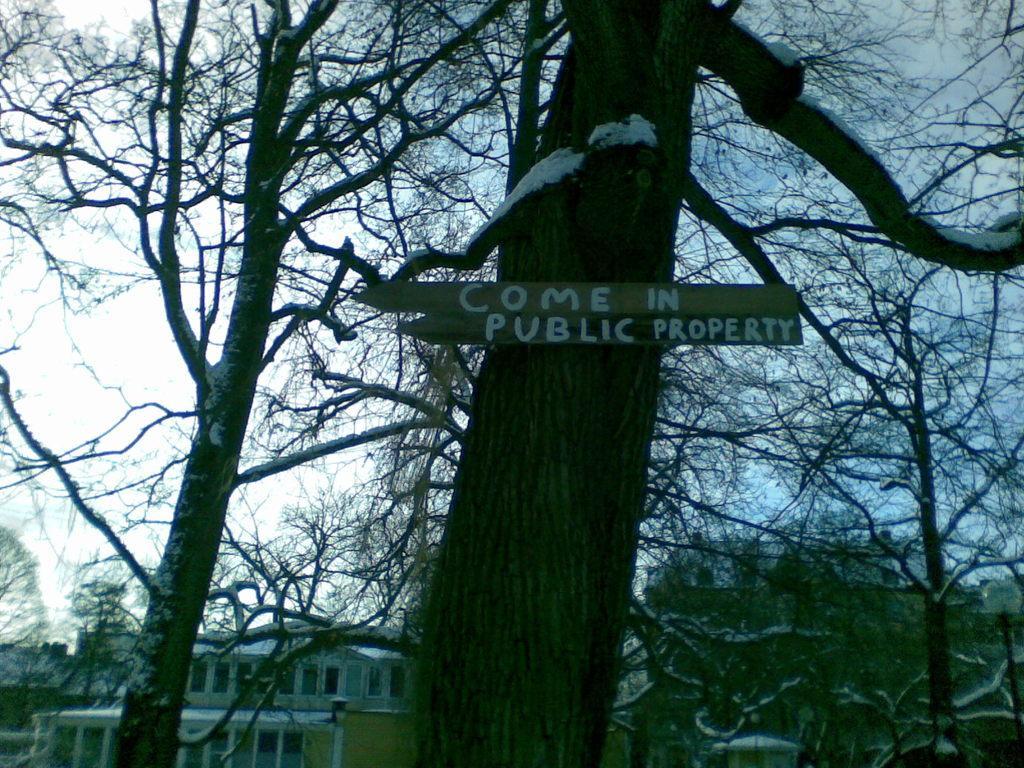Can you describe this image briefly? In this image we can see trees and a name board to one of it, buildings and sky. 